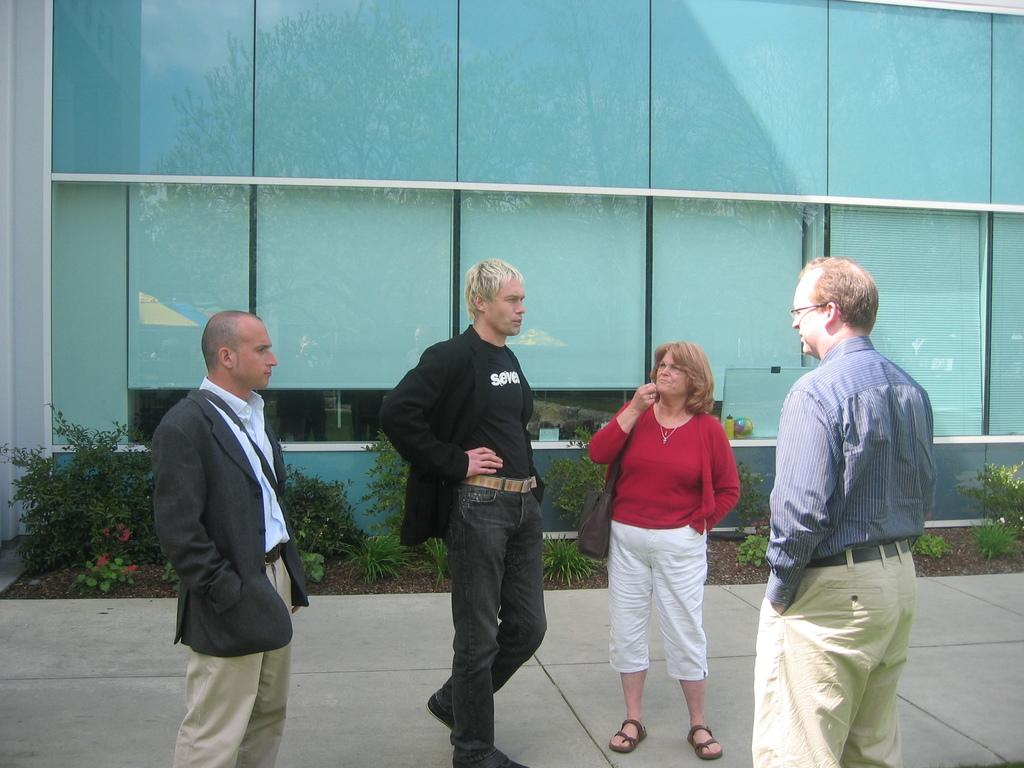How many people are in the image? There are three men and a woman standing in the image, making a total of four people. Can you describe the appearance of one of the men? The right side man is wearing spectacles. What are the people in the image wearing? The people in the image are wearing clothes. What type of vegetation can be seen in the image? There is a plant visible in the image. What architectural feature is present in the image? There is a glass wall in the image. What type of path is visible in the image? There is a footpath in the image. What type of shirt is the woman wearing in the image? The provided facts do not mention the type of shirt the woman is wearing, so we cannot answer this question definitively. Can you see any trains in the image? There are no trains visible in the image. Is there an ocean visible in the image? There is no ocean present in the image. 